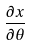<formula> <loc_0><loc_0><loc_500><loc_500>\frac { \partial x } { \partial \theta }</formula> 